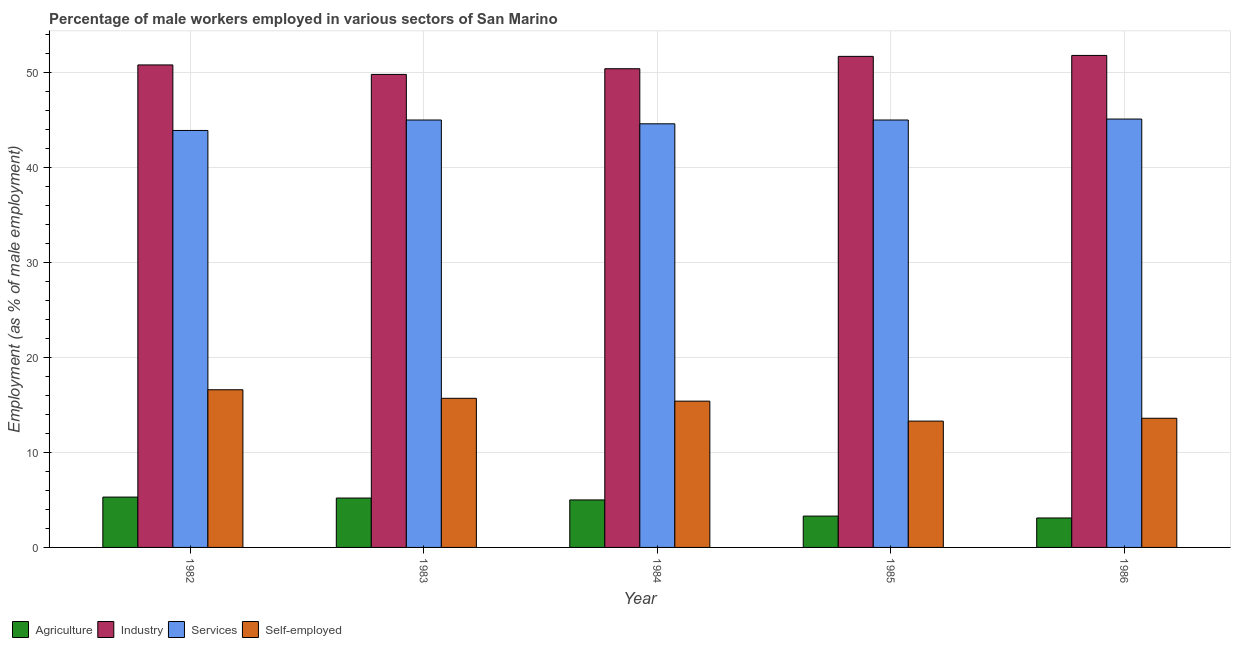What is the percentage of male workers in industry in 1984?
Your answer should be very brief. 50.4. Across all years, what is the maximum percentage of male workers in industry?
Make the answer very short. 51.8. Across all years, what is the minimum percentage of male workers in services?
Your answer should be very brief. 43.9. In which year was the percentage of male workers in services maximum?
Your answer should be very brief. 1986. In which year was the percentage of male workers in industry minimum?
Offer a terse response. 1983. What is the total percentage of self employed male workers in the graph?
Make the answer very short. 74.6. What is the difference between the percentage of male workers in services in 1984 and that in 1986?
Ensure brevity in your answer.  -0.5. What is the difference between the percentage of male workers in services in 1983 and the percentage of self employed male workers in 1984?
Provide a short and direct response. 0.4. What is the average percentage of male workers in industry per year?
Offer a terse response. 50.9. What is the ratio of the percentage of self employed male workers in 1982 to that in 1984?
Offer a very short reply. 1.08. Is the difference between the percentage of male workers in services in 1982 and 1985 greater than the difference between the percentage of male workers in agriculture in 1982 and 1985?
Give a very brief answer. No. What is the difference between the highest and the second highest percentage of male workers in agriculture?
Keep it short and to the point. 0.1. What is the difference between the highest and the lowest percentage of male workers in services?
Ensure brevity in your answer.  1.2. In how many years, is the percentage of male workers in agriculture greater than the average percentage of male workers in agriculture taken over all years?
Make the answer very short. 3. What does the 3rd bar from the left in 1985 represents?
Ensure brevity in your answer.  Services. What does the 4th bar from the right in 1984 represents?
Provide a succinct answer. Agriculture. How many years are there in the graph?
Provide a short and direct response. 5. What is the difference between two consecutive major ticks on the Y-axis?
Your response must be concise. 10. Does the graph contain any zero values?
Offer a very short reply. No. Does the graph contain grids?
Make the answer very short. Yes. Where does the legend appear in the graph?
Provide a succinct answer. Bottom left. How many legend labels are there?
Your answer should be very brief. 4. How are the legend labels stacked?
Your response must be concise. Horizontal. What is the title of the graph?
Offer a terse response. Percentage of male workers employed in various sectors of San Marino. What is the label or title of the X-axis?
Your response must be concise. Year. What is the label or title of the Y-axis?
Your response must be concise. Employment (as % of male employment). What is the Employment (as % of male employment) in Agriculture in 1982?
Provide a short and direct response. 5.3. What is the Employment (as % of male employment) in Industry in 1982?
Give a very brief answer. 50.8. What is the Employment (as % of male employment) of Services in 1982?
Make the answer very short. 43.9. What is the Employment (as % of male employment) in Self-employed in 1982?
Ensure brevity in your answer.  16.6. What is the Employment (as % of male employment) in Agriculture in 1983?
Ensure brevity in your answer.  5.2. What is the Employment (as % of male employment) in Industry in 1983?
Offer a very short reply. 49.8. What is the Employment (as % of male employment) of Services in 1983?
Provide a succinct answer. 45. What is the Employment (as % of male employment) of Self-employed in 1983?
Keep it short and to the point. 15.7. What is the Employment (as % of male employment) in Industry in 1984?
Offer a terse response. 50.4. What is the Employment (as % of male employment) in Services in 1984?
Ensure brevity in your answer.  44.6. What is the Employment (as % of male employment) in Self-employed in 1984?
Your response must be concise. 15.4. What is the Employment (as % of male employment) of Agriculture in 1985?
Your answer should be compact. 3.3. What is the Employment (as % of male employment) of Industry in 1985?
Your response must be concise. 51.7. What is the Employment (as % of male employment) of Self-employed in 1985?
Your answer should be very brief. 13.3. What is the Employment (as % of male employment) in Agriculture in 1986?
Your response must be concise. 3.1. What is the Employment (as % of male employment) of Industry in 1986?
Offer a terse response. 51.8. What is the Employment (as % of male employment) of Services in 1986?
Provide a succinct answer. 45.1. What is the Employment (as % of male employment) in Self-employed in 1986?
Give a very brief answer. 13.6. Across all years, what is the maximum Employment (as % of male employment) in Agriculture?
Provide a short and direct response. 5.3. Across all years, what is the maximum Employment (as % of male employment) of Industry?
Your answer should be very brief. 51.8. Across all years, what is the maximum Employment (as % of male employment) in Services?
Your response must be concise. 45.1. Across all years, what is the maximum Employment (as % of male employment) in Self-employed?
Provide a short and direct response. 16.6. Across all years, what is the minimum Employment (as % of male employment) in Agriculture?
Keep it short and to the point. 3.1. Across all years, what is the minimum Employment (as % of male employment) in Industry?
Your answer should be compact. 49.8. Across all years, what is the minimum Employment (as % of male employment) in Services?
Your response must be concise. 43.9. Across all years, what is the minimum Employment (as % of male employment) in Self-employed?
Provide a succinct answer. 13.3. What is the total Employment (as % of male employment) in Agriculture in the graph?
Offer a very short reply. 21.9. What is the total Employment (as % of male employment) of Industry in the graph?
Provide a short and direct response. 254.5. What is the total Employment (as % of male employment) of Services in the graph?
Make the answer very short. 223.6. What is the total Employment (as % of male employment) in Self-employed in the graph?
Make the answer very short. 74.6. What is the difference between the Employment (as % of male employment) of Services in 1982 and that in 1983?
Provide a short and direct response. -1.1. What is the difference between the Employment (as % of male employment) in Self-employed in 1982 and that in 1983?
Give a very brief answer. 0.9. What is the difference between the Employment (as % of male employment) of Self-employed in 1982 and that in 1984?
Make the answer very short. 1.2. What is the difference between the Employment (as % of male employment) in Industry in 1982 and that in 1985?
Offer a terse response. -0.9. What is the difference between the Employment (as % of male employment) in Agriculture in 1982 and that in 1986?
Make the answer very short. 2.2. What is the difference between the Employment (as % of male employment) in Industry in 1983 and that in 1984?
Keep it short and to the point. -0.6. What is the difference between the Employment (as % of male employment) of Services in 1983 and that in 1984?
Make the answer very short. 0.4. What is the difference between the Employment (as % of male employment) of Self-employed in 1983 and that in 1984?
Provide a short and direct response. 0.3. What is the difference between the Employment (as % of male employment) of Agriculture in 1983 and that in 1985?
Keep it short and to the point. 1.9. What is the difference between the Employment (as % of male employment) in Industry in 1983 and that in 1985?
Offer a terse response. -1.9. What is the difference between the Employment (as % of male employment) in Agriculture in 1983 and that in 1986?
Your response must be concise. 2.1. What is the difference between the Employment (as % of male employment) of Industry in 1983 and that in 1986?
Offer a terse response. -2. What is the difference between the Employment (as % of male employment) of Services in 1983 and that in 1986?
Provide a succinct answer. -0.1. What is the difference between the Employment (as % of male employment) in Agriculture in 1984 and that in 1985?
Ensure brevity in your answer.  1.7. What is the difference between the Employment (as % of male employment) of Industry in 1984 and that in 1985?
Offer a very short reply. -1.3. What is the difference between the Employment (as % of male employment) of Self-employed in 1984 and that in 1985?
Ensure brevity in your answer.  2.1. What is the difference between the Employment (as % of male employment) in Services in 1984 and that in 1986?
Offer a terse response. -0.5. What is the difference between the Employment (as % of male employment) of Self-employed in 1984 and that in 1986?
Offer a very short reply. 1.8. What is the difference between the Employment (as % of male employment) in Agriculture in 1985 and that in 1986?
Provide a short and direct response. 0.2. What is the difference between the Employment (as % of male employment) of Agriculture in 1982 and the Employment (as % of male employment) of Industry in 1983?
Make the answer very short. -44.5. What is the difference between the Employment (as % of male employment) of Agriculture in 1982 and the Employment (as % of male employment) of Services in 1983?
Provide a succinct answer. -39.7. What is the difference between the Employment (as % of male employment) of Industry in 1982 and the Employment (as % of male employment) of Self-employed in 1983?
Provide a succinct answer. 35.1. What is the difference between the Employment (as % of male employment) in Services in 1982 and the Employment (as % of male employment) in Self-employed in 1983?
Your response must be concise. 28.2. What is the difference between the Employment (as % of male employment) of Agriculture in 1982 and the Employment (as % of male employment) of Industry in 1984?
Your response must be concise. -45.1. What is the difference between the Employment (as % of male employment) in Agriculture in 1982 and the Employment (as % of male employment) in Services in 1984?
Ensure brevity in your answer.  -39.3. What is the difference between the Employment (as % of male employment) in Agriculture in 1982 and the Employment (as % of male employment) in Self-employed in 1984?
Your response must be concise. -10.1. What is the difference between the Employment (as % of male employment) of Industry in 1982 and the Employment (as % of male employment) of Self-employed in 1984?
Provide a succinct answer. 35.4. What is the difference between the Employment (as % of male employment) of Services in 1982 and the Employment (as % of male employment) of Self-employed in 1984?
Your response must be concise. 28.5. What is the difference between the Employment (as % of male employment) in Agriculture in 1982 and the Employment (as % of male employment) in Industry in 1985?
Keep it short and to the point. -46.4. What is the difference between the Employment (as % of male employment) of Agriculture in 1982 and the Employment (as % of male employment) of Services in 1985?
Make the answer very short. -39.7. What is the difference between the Employment (as % of male employment) in Industry in 1982 and the Employment (as % of male employment) in Services in 1985?
Ensure brevity in your answer.  5.8. What is the difference between the Employment (as % of male employment) of Industry in 1982 and the Employment (as % of male employment) of Self-employed in 1985?
Your answer should be very brief. 37.5. What is the difference between the Employment (as % of male employment) in Services in 1982 and the Employment (as % of male employment) in Self-employed in 1985?
Offer a very short reply. 30.6. What is the difference between the Employment (as % of male employment) in Agriculture in 1982 and the Employment (as % of male employment) in Industry in 1986?
Offer a terse response. -46.5. What is the difference between the Employment (as % of male employment) of Agriculture in 1982 and the Employment (as % of male employment) of Services in 1986?
Give a very brief answer. -39.8. What is the difference between the Employment (as % of male employment) of Industry in 1982 and the Employment (as % of male employment) of Services in 1986?
Provide a short and direct response. 5.7. What is the difference between the Employment (as % of male employment) in Industry in 1982 and the Employment (as % of male employment) in Self-employed in 1986?
Provide a succinct answer. 37.2. What is the difference between the Employment (as % of male employment) of Services in 1982 and the Employment (as % of male employment) of Self-employed in 1986?
Your answer should be very brief. 30.3. What is the difference between the Employment (as % of male employment) of Agriculture in 1983 and the Employment (as % of male employment) of Industry in 1984?
Make the answer very short. -45.2. What is the difference between the Employment (as % of male employment) in Agriculture in 1983 and the Employment (as % of male employment) in Services in 1984?
Ensure brevity in your answer.  -39.4. What is the difference between the Employment (as % of male employment) of Industry in 1983 and the Employment (as % of male employment) of Services in 1984?
Your answer should be very brief. 5.2. What is the difference between the Employment (as % of male employment) in Industry in 1983 and the Employment (as % of male employment) in Self-employed in 1984?
Make the answer very short. 34.4. What is the difference between the Employment (as % of male employment) of Services in 1983 and the Employment (as % of male employment) of Self-employed in 1984?
Provide a succinct answer. 29.6. What is the difference between the Employment (as % of male employment) in Agriculture in 1983 and the Employment (as % of male employment) in Industry in 1985?
Make the answer very short. -46.5. What is the difference between the Employment (as % of male employment) in Agriculture in 1983 and the Employment (as % of male employment) in Services in 1985?
Your answer should be compact. -39.8. What is the difference between the Employment (as % of male employment) in Agriculture in 1983 and the Employment (as % of male employment) in Self-employed in 1985?
Provide a short and direct response. -8.1. What is the difference between the Employment (as % of male employment) in Industry in 1983 and the Employment (as % of male employment) in Services in 1985?
Provide a succinct answer. 4.8. What is the difference between the Employment (as % of male employment) in Industry in 1983 and the Employment (as % of male employment) in Self-employed in 1985?
Keep it short and to the point. 36.5. What is the difference between the Employment (as % of male employment) of Services in 1983 and the Employment (as % of male employment) of Self-employed in 1985?
Your answer should be very brief. 31.7. What is the difference between the Employment (as % of male employment) in Agriculture in 1983 and the Employment (as % of male employment) in Industry in 1986?
Give a very brief answer. -46.6. What is the difference between the Employment (as % of male employment) of Agriculture in 1983 and the Employment (as % of male employment) of Services in 1986?
Provide a succinct answer. -39.9. What is the difference between the Employment (as % of male employment) of Industry in 1983 and the Employment (as % of male employment) of Self-employed in 1986?
Ensure brevity in your answer.  36.2. What is the difference between the Employment (as % of male employment) of Services in 1983 and the Employment (as % of male employment) of Self-employed in 1986?
Ensure brevity in your answer.  31.4. What is the difference between the Employment (as % of male employment) of Agriculture in 1984 and the Employment (as % of male employment) of Industry in 1985?
Offer a very short reply. -46.7. What is the difference between the Employment (as % of male employment) of Agriculture in 1984 and the Employment (as % of male employment) of Services in 1985?
Offer a very short reply. -40. What is the difference between the Employment (as % of male employment) of Agriculture in 1984 and the Employment (as % of male employment) of Self-employed in 1985?
Ensure brevity in your answer.  -8.3. What is the difference between the Employment (as % of male employment) in Industry in 1984 and the Employment (as % of male employment) in Services in 1985?
Your answer should be very brief. 5.4. What is the difference between the Employment (as % of male employment) of Industry in 1984 and the Employment (as % of male employment) of Self-employed in 1985?
Your answer should be very brief. 37.1. What is the difference between the Employment (as % of male employment) of Services in 1984 and the Employment (as % of male employment) of Self-employed in 1985?
Make the answer very short. 31.3. What is the difference between the Employment (as % of male employment) of Agriculture in 1984 and the Employment (as % of male employment) of Industry in 1986?
Your response must be concise. -46.8. What is the difference between the Employment (as % of male employment) of Agriculture in 1984 and the Employment (as % of male employment) of Services in 1986?
Provide a short and direct response. -40.1. What is the difference between the Employment (as % of male employment) of Agriculture in 1984 and the Employment (as % of male employment) of Self-employed in 1986?
Keep it short and to the point. -8.6. What is the difference between the Employment (as % of male employment) of Industry in 1984 and the Employment (as % of male employment) of Self-employed in 1986?
Give a very brief answer. 36.8. What is the difference between the Employment (as % of male employment) in Agriculture in 1985 and the Employment (as % of male employment) in Industry in 1986?
Offer a terse response. -48.5. What is the difference between the Employment (as % of male employment) in Agriculture in 1985 and the Employment (as % of male employment) in Services in 1986?
Your answer should be very brief. -41.8. What is the difference between the Employment (as % of male employment) of Industry in 1985 and the Employment (as % of male employment) of Self-employed in 1986?
Provide a short and direct response. 38.1. What is the difference between the Employment (as % of male employment) of Services in 1985 and the Employment (as % of male employment) of Self-employed in 1986?
Provide a short and direct response. 31.4. What is the average Employment (as % of male employment) of Agriculture per year?
Your answer should be very brief. 4.38. What is the average Employment (as % of male employment) of Industry per year?
Your response must be concise. 50.9. What is the average Employment (as % of male employment) of Services per year?
Provide a short and direct response. 44.72. What is the average Employment (as % of male employment) of Self-employed per year?
Your answer should be very brief. 14.92. In the year 1982, what is the difference between the Employment (as % of male employment) in Agriculture and Employment (as % of male employment) in Industry?
Keep it short and to the point. -45.5. In the year 1982, what is the difference between the Employment (as % of male employment) of Agriculture and Employment (as % of male employment) of Services?
Keep it short and to the point. -38.6. In the year 1982, what is the difference between the Employment (as % of male employment) of Agriculture and Employment (as % of male employment) of Self-employed?
Your response must be concise. -11.3. In the year 1982, what is the difference between the Employment (as % of male employment) in Industry and Employment (as % of male employment) in Self-employed?
Your answer should be compact. 34.2. In the year 1982, what is the difference between the Employment (as % of male employment) in Services and Employment (as % of male employment) in Self-employed?
Offer a terse response. 27.3. In the year 1983, what is the difference between the Employment (as % of male employment) in Agriculture and Employment (as % of male employment) in Industry?
Provide a succinct answer. -44.6. In the year 1983, what is the difference between the Employment (as % of male employment) in Agriculture and Employment (as % of male employment) in Services?
Provide a succinct answer. -39.8. In the year 1983, what is the difference between the Employment (as % of male employment) of Industry and Employment (as % of male employment) of Self-employed?
Offer a very short reply. 34.1. In the year 1983, what is the difference between the Employment (as % of male employment) in Services and Employment (as % of male employment) in Self-employed?
Your response must be concise. 29.3. In the year 1984, what is the difference between the Employment (as % of male employment) of Agriculture and Employment (as % of male employment) of Industry?
Ensure brevity in your answer.  -45.4. In the year 1984, what is the difference between the Employment (as % of male employment) in Agriculture and Employment (as % of male employment) in Services?
Make the answer very short. -39.6. In the year 1984, what is the difference between the Employment (as % of male employment) of Services and Employment (as % of male employment) of Self-employed?
Provide a succinct answer. 29.2. In the year 1985, what is the difference between the Employment (as % of male employment) in Agriculture and Employment (as % of male employment) in Industry?
Your answer should be compact. -48.4. In the year 1985, what is the difference between the Employment (as % of male employment) in Agriculture and Employment (as % of male employment) in Services?
Offer a very short reply. -41.7. In the year 1985, what is the difference between the Employment (as % of male employment) in Industry and Employment (as % of male employment) in Services?
Offer a terse response. 6.7. In the year 1985, what is the difference between the Employment (as % of male employment) in Industry and Employment (as % of male employment) in Self-employed?
Ensure brevity in your answer.  38.4. In the year 1985, what is the difference between the Employment (as % of male employment) of Services and Employment (as % of male employment) of Self-employed?
Ensure brevity in your answer.  31.7. In the year 1986, what is the difference between the Employment (as % of male employment) in Agriculture and Employment (as % of male employment) in Industry?
Ensure brevity in your answer.  -48.7. In the year 1986, what is the difference between the Employment (as % of male employment) of Agriculture and Employment (as % of male employment) of Services?
Offer a terse response. -42. In the year 1986, what is the difference between the Employment (as % of male employment) in Agriculture and Employment (as % of male employment) in Self-employed?
Your response must be concise. -10.5. In the year 1986, what is the difference between the Employment (as % of male employment) in Industry and Employment (as % of male employment) in Services?
Provide a short and direct response. 6.7. In the year 1986, what is the difference between the Employment (as % of male employment) in Industry and Employment (as % of male employment) in Self-employed?
Offer a terse response. 38.2. In the year 1986, what is the difference between the Employment (as % of male employment) of Services and Employment (as % of male employment) of Self-employed?
Provide a succinct answer. 31.5. What is the ratio of the Employment (as % of male employment) in Agriculture in 1982 to that in 1983?
Keep it short and to the point. 1.02. What is the ratio of the Employment (as % of male employment) in Industry in 1982 to that in 1983?
Your response must be concise. 1.02. What is the ratio of the Employment (as % of male employment) of Services in 1982 to that in 1983?
Provide a short and direct response. 0.98. What is the ratio of the Employment (as % of male employment) in Self-employed in 1982 to that in 1983?
Give a very brief answer. 1.06. What is the ratio of the Employment (as % of male employment) in Agriculture in 1982 to that in 1984?
Your response must be concise. 1.06. What is the ratio of the Employment (as % of male employment) of Industry in 1982 to that in 1984?
Provide a short and direct response. 1.01. What is the ratio of the Employment (as % of male employment) in Services in 1982 to that in 1984?
Your response must be concise. 0.98. What is the ratio of the Employment (as % of male employment) of Self-employed in 1982 to that in 1984?
Offer a very short reply. 1.08. What is the ratio of the Employment (as % of male employment) of Agriculture in 1982 to that in 1985?
Provide a short and direct response. 1.61. What is the ratio of the Employment (as % of male employment) of Industry in 1982 to that in 1985?
Your response must be concise. 0.98. What is the ratio of the Employment (as % of male employment) of Services in 1982 to that in 1985?
Your answer should be compact. 0.98. What is the ratio of the Employment (as % of male employment) in Self-employed in 1982 to that in 1985?
Ensure brevity in your answer.  1.25. What is the ratio of the Employment (as % of male employment) in Agriculture in 1982 to that in 1986?
Give a very brief answer. 1.71. What is the ratio of the Employment (as % of male employment) in Industry in 1982 to that in 1986?
Provide a short and direct response. 0.98. What is the ratio of the Employment (as % of male employment) in Services in 1982 to that in 1986?
Your answer should be very brief. 0.97. What is the ratio of the Employment (as % of male employment) of Self-employed in 1982 to that in 1986?
Make the answer very short. 1.22. What is the ratio of the Employment (as % of male employment) of Agriculture in 1983 to that in 1984?
Your answer should be compact. 1.04. What is the ratio of the Employment (as % of male employment) of Self-employed in 1983 to that in 1984?
Your answer should be very brief. 1.02. What is the ratio of the Employment (as % of male employment) in Agriculture in 1983 to that in 1985?
Your response must be concise. 1.58. What is the ratio of the Employment (as % of male employment) of Industry in 1983 to that in 1985?
Your answer should be compact. 0.96. What is the ratio of the Employment (as % of male employment) in Self-employed in 1983 to that in 1985?
Offer a very short reply. 1.18. What is the ratio of the Employment (as % of male employment) in Agriculture in 1983 to that in 1986?
Make the answer very short. 1.68. What is the ratio of the Employment (as % of male employment) in Industry in 1983 to that in 1986?
Provide a short and direct response. 0.96. What is the ratio of the Employment (as % of male employment) in Self-employed in 1983 to that in 1986?
Offer a terse response. 1.15. What is the ratio of the Employment (as % of male employment) of Agriculture in 1984 to that in 1985?
Ensure brevity in your answer.  1.52. What is the ratio of the Employment (as % of male employment) of Industry in 1984 to that in 1985?
Your answer should be compact. 0.97. What is the ratio of the Employment (as % of male employment) of Self-employed in 1984 to that in 1985?
Provide a short and direct response. 1.16. What is the ratio of the Employment (as % of male employment) of Agriculture in 1984 to that in 1986?
Your answer should be compact. 1.61. What is the ratio of the Employment (as % of male employment) of Services in 1984 to that in 1986?
Your answer should be compact. 0.99. What is the ratio of the Employment (as % of male employment) of Self-employed in 1984 to that in 1986?
Make the answer very short. 1.13. What is the ratio of the Employment (as % of male employment) of Agriculture in 1985 to that in 1986?
Make the answer very short. 1.06. What is the ratio of the Employment (as % of male employment) in Services in 1985 to that in 1986?
Give a very brief answer. 1. What is the ratio of the Employment (as % of male employment) in Self-employed in 1985 to that in 1986?
Offer a terse response. 0.98. What is the difference between the highest and the second highest Employment (as % of male employment) in Agriculture?
Make the answer very short. 0.1. What is the difference between the highest and the second highest Employment (as % of male employment) of Industry?
Your answer should be very brief. 0.1. What is the difference between the highest and the second highest Employment (as % of male employment) of Services?
Keep it short and to the point. 0.1. What is the difference between the highest and the lowest Employment (as % of male employment) in Agriculture?
Make the answer very short. 2.2. What is the difference between the highest and the lowest Employment (as % of male employment) of Services?
Keep it short and to the point. 1.2. What is the difference between the highest and the lowest Employment (as % of male employment) in Self-employed?
Offer a terse response. 3.3. 